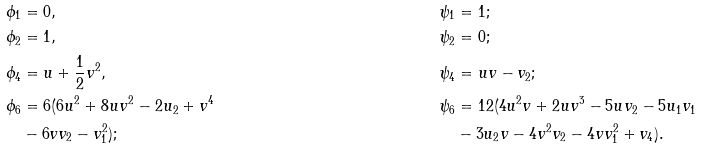Convert formula to latex. <formula><loc_0><loc_0><loc_500><loc_500>\phi _ { 1 } & = 0 , & \psi _ { 1 } & = 1 ; \\ \phi _ { 2 } & = 1 , & \psi _ { 2 } & = 0 ; \\ \phi _ { 4 } & = u + \frac { 1 } { 2 } v ^ { 2 } , & \psi _ { 4 } & = u v - v _ { 2 } ; \\ \phi _ { 6 } & = 6 ( 6 u ^ { 2 } + 8 u v ^ { 2 } - 2 u _ { 2 } + v ^ { 4 } & \psi _ { 6 } & = 1 2 ( 4 u ^ { 2 } v + 2 u v ^ { 3 } - 5 u v _ { 2 } - 5 u _ { 1 } v _ { 1 } \\ & - 6 v v _ { 2 } - v _ { 1 } ^ { 2 } ) ; & & - 3 u _ { 2 } v - 4 v ^ { 2 } v _ { 2 } - 4 v v _ { 1 } ^ { 2 } + v _ { 4 } ) .</formula> 